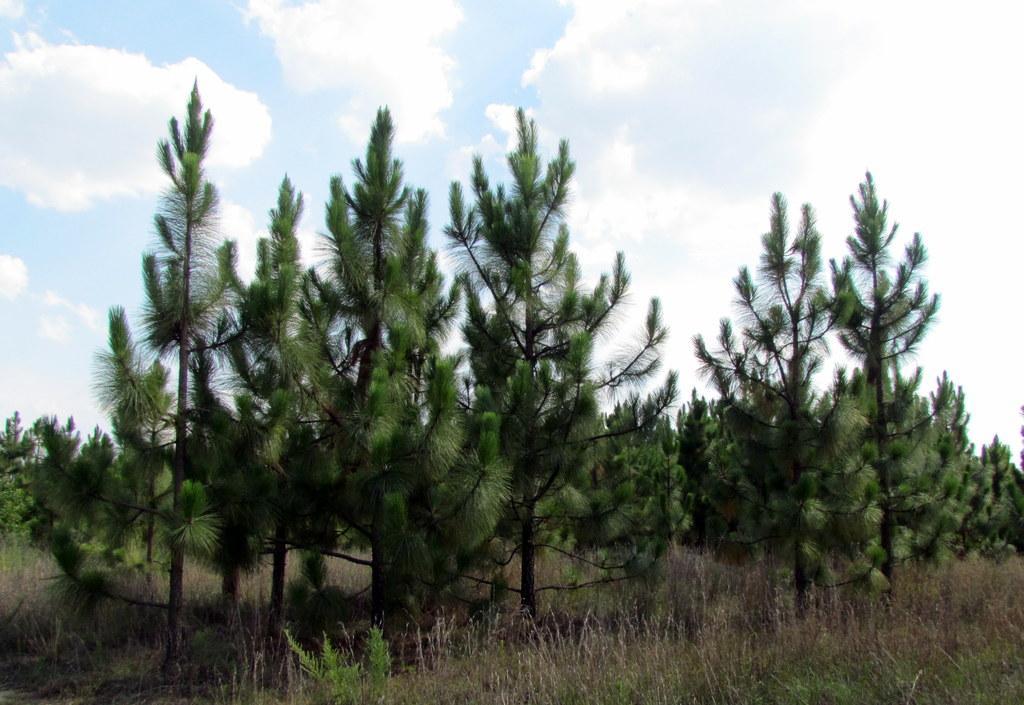Please provide a concise description of this image. In this image there is the sky, there are clouds in the sky, there are trees, there are trees truncated towards the right of the image, there is tree truncated towards the left of the image, there are plants truncated towards the bottom of the image. 